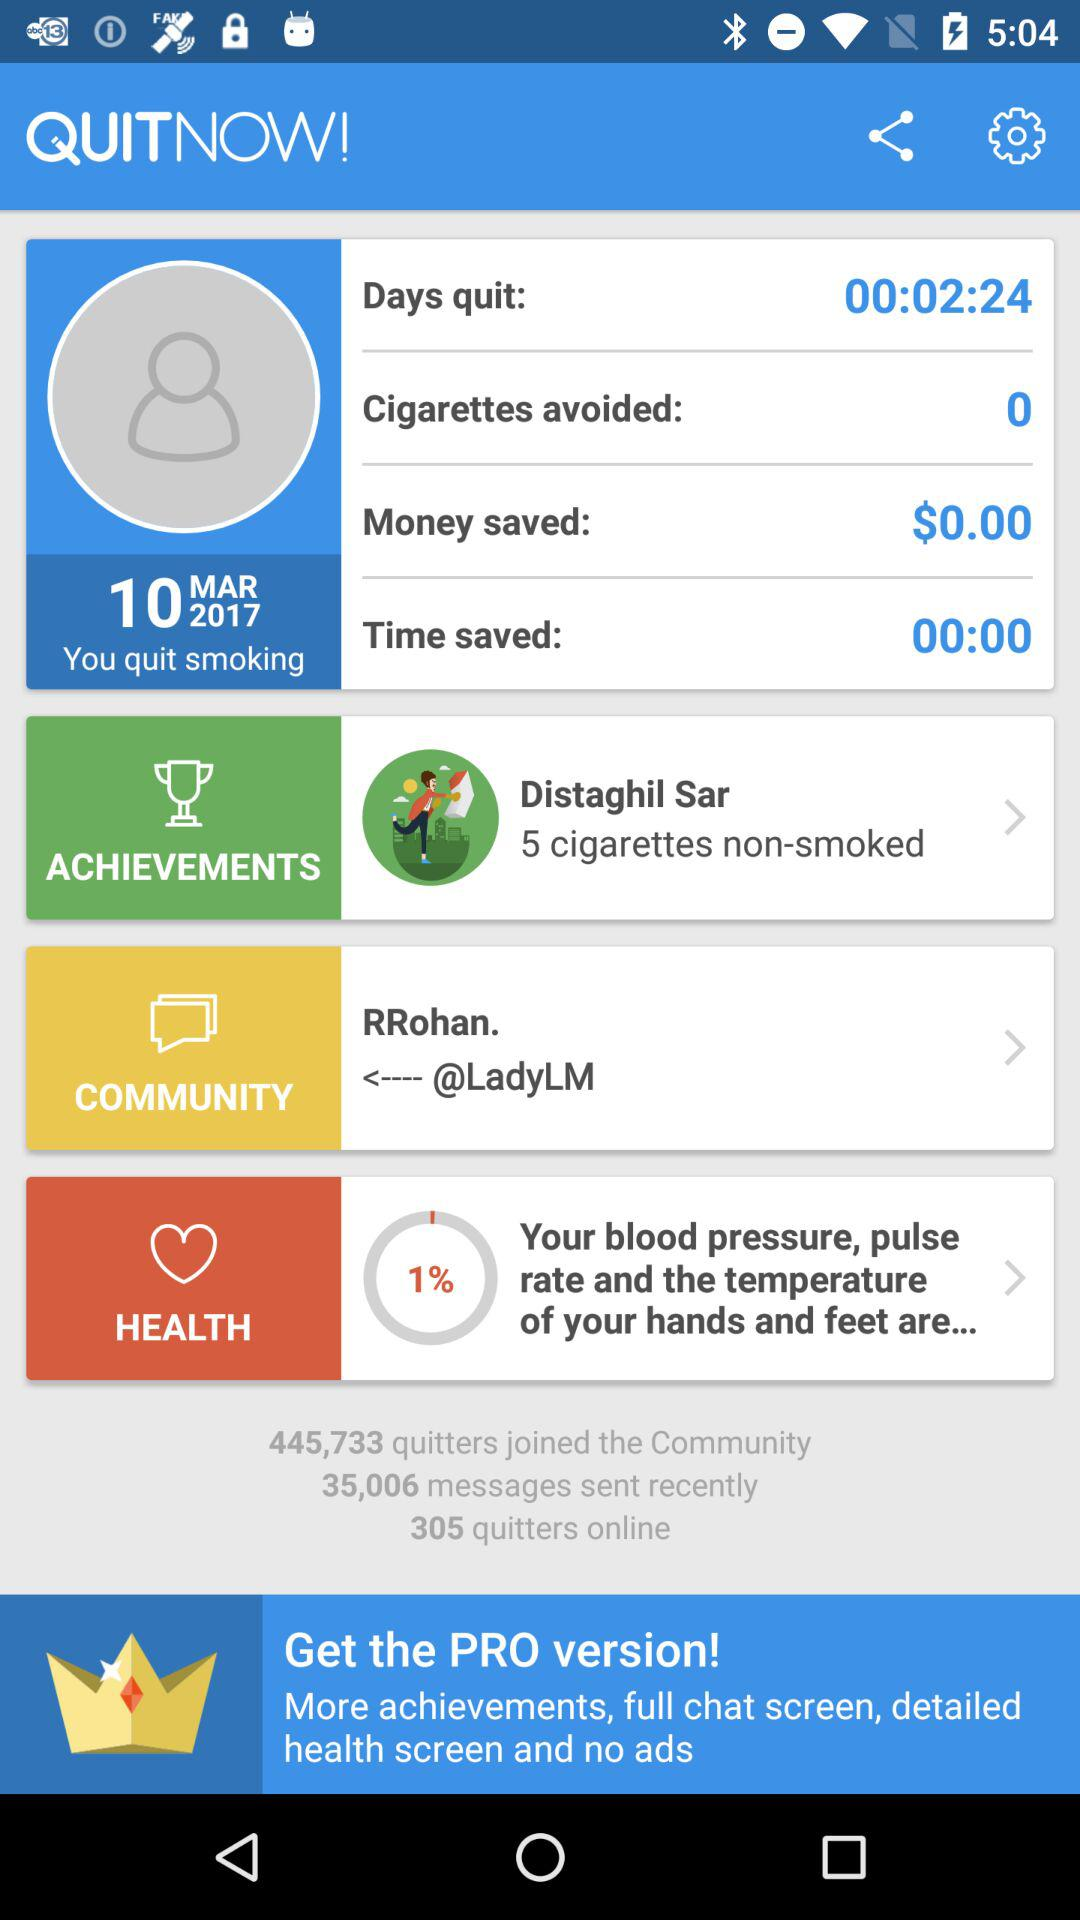How much money is saved? The saved money is $0.00. 